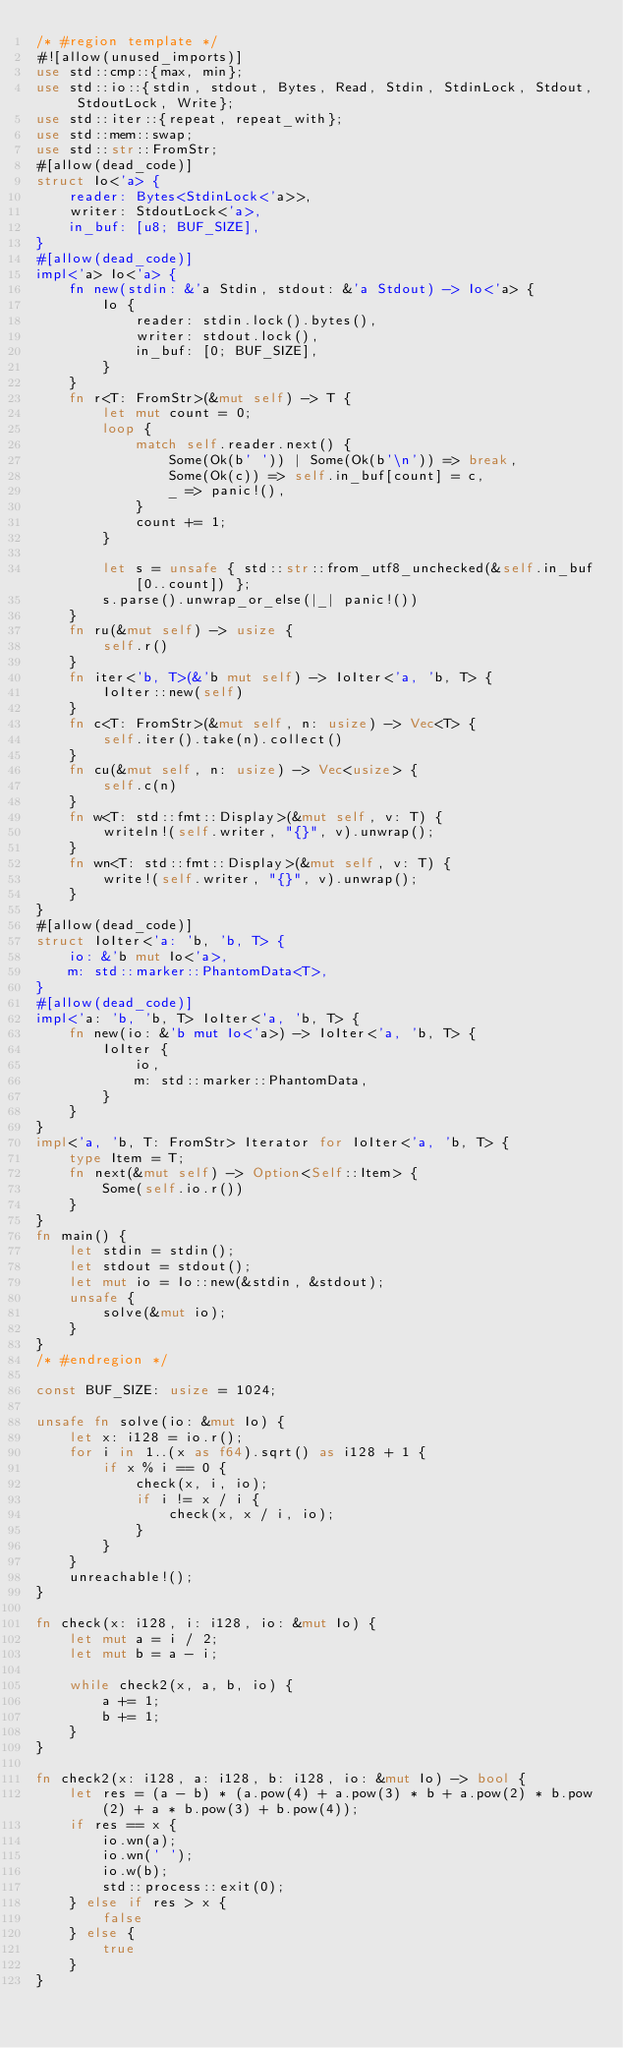<code> <loc_0><loc_0><loc_500><loc_500><_Rust_>/* #region template */
#![allow(unused_imports)]
use std::cmp::{max, min};
use std::io::{stdin, stdout, Bytes, Read, Stdin, StdinLock, Stdout, StdoutLock, Write};
use std::iter::{repeat, repeat_with};
use std::mem::swap;
use std::str::FromStr;
#[allow(dead_code)]
struct Io<'a> {
    reader: Bytes<StdinLock<'a>>,
    writer: StdoutLock<'a>,
    in_buf: [u8; BUF_SIZE],
}
#[allow(dead_code)]
impl<'a> Io<'a> {
    fn new(stdin: &'a Stdin, stdout: &'a Stdout) -> Io<'a> {
        Io {
            reader: stdin.lock().bytes(),
            writer: stdout.lock(),
            in_buf: [0; BUF_SIZE],
        }
    }
    fn r<T: FromStr>(&mut self) -> T {
        let mut count = 0;
        loop {
            match self.reader.next() {
                Some(Ok(b' ')) | Some(Ok(b'\n')) => break,
                Some(Ok(c)) => self.in_buf[count] = c,
                _ => panic!(),
            }
            count += 1;
        }

        let s = unsafe { std::str::from_utf8_unchecked(&self.in_buf[0..count]) };
        s.parse().unwrap_or_else(|_| panic!())
    }
    fn ru(&mut self) -> usize {
        self.r()
    }
    fn iter<'b, T>(&'b mut self) -> IoIter<'a, 'b, T> {
        IoIter::new(self)
    }
    fn c<T: FromStr>(&mut self, n: usize) -> Vec<T> {
        self.iter().take(n).collect()
    }
    fn cu(&mut self, n: usize) -> Vec<usize> {
        self.c(n)
    }
    fn w<T: std::fmt::Display>(&mut self, v: T) {
        writeln!(self.writer, "{}", v).unwrap();
    }
    fn wn<T: std::fmt::Display>(&mut self, v: T) {
        write!(self.writer, "{}", v).unwrap();
    }
}
#[allow(dead_code)]
struct IoIter<'a: 'b, 'b, T> {
    io: &'b mut Io<'a>,
    m: std::marker::PhantomData<T>,
}
#[allow(dead_code)]
impl<'a: 'b, 'b, T> IoIter<'a, 'b, T> {
    fn new(io: &'b mut Io<'a>) -> IoIter<'a, 'b, T> {
        IoIter {
            io,
            m: std::marker::PhantomData,
        }
    }
}
impl<'a, 'b, T: FromStr> Iterator for IoIter<'a, 'b, T> {
    type Item = T;
    fn next(&mut self) -> Option<Self::Item> {
        Some(self.io.r())
    }
}
fn main() {
    let stdin = stdin();
    let stdout = stdout();
    let mut io = Io::new(&stdin, &stdout);
    unsafe {
        solve(&mut io);
    }
}
/* #endregion */

const BUF_SIZE: usize = 1024;

unsafe fn solve(io: &mut Io) {
    let x: i128 = io.r();
    for i in 1..(x as f64).sqrt() as i128 + 1 {
        if x % i == 0 {
            check(x, i, io);
            if i != x / i {
                check(x, x / i, io);
            }
        }
    }
    unreachable!();
}

fn check(x: i128, i: i128, io: &mut Io) {
    let mut a = i / 2;
    let mut b = a - i;

    while check2(x, a, b, io) {
        a += 1;
        b += 1;
    }
}

fn check2(x: i128, a: i128, b: i128, io: &mut Io) -> bool {
    let res = (a - b) * (a.pow(4) + a.pow(3) * b + a.pow(2) * b.pow(2) + a * b.pow(3) + b.pow(4));
    if res == x {
        io.wn(a);
        io.wn(' ');
        io.w(b);
        std::process::exit(0);
    } else if res > x {
        false
    } else {
        true
    }
}
</code> 